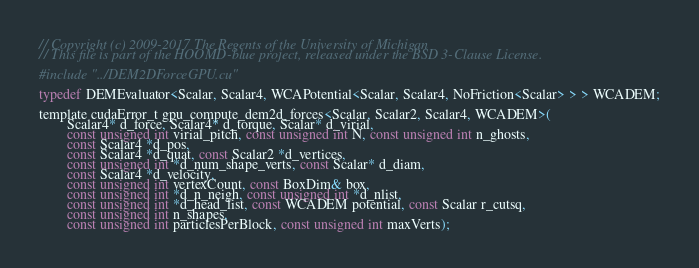<code> <loc_0><loc_0><loc_500><loc_500><_Cuda_>// Copyright (c) 2009-2017 The Regents of the University of Michigan
// This file is part of the HOOMD-blue project, released under the BSD 3-Clause License.

#include "../DEM2DForceGPU.cu"

typedef DEMEvaluator<Scalar, Scalar4, WCAPotential<Scalar, Scalar4, NoFriction<Scalar> > > WCADEM;

template cudaError_t gpu_compute_dem2d_forces<Scalar, Scalar2, Scalar4, WCADEM>(
        Scalar4* d_force, Scalar4* d_torque, Scalar* d_virial,
        const unsigned int virial_pitch, const unsigned int N, const unsigned int n_ghosts,
        const Scalar4 *d_pos,
        const Scalar4 *d_quat, const Scalar2 *d_vertices,
        const unsigned int *d_num_shape_verts, const Scalar* d_diam,
        const Scalar4 *d_velocity,
        const unsigned int vertexCount, const BoxDim& box,
        const unsigned int *d_n_neigh, const unsigned int *d_nlist,
        const unsigned int *d_head_list, const WCADEM potential, const Scalar r_cutsq,
        const unsigned int n_shapes,
        const unsigned int particlesPerBlock, const unsigned int maxVerts);
</code> 